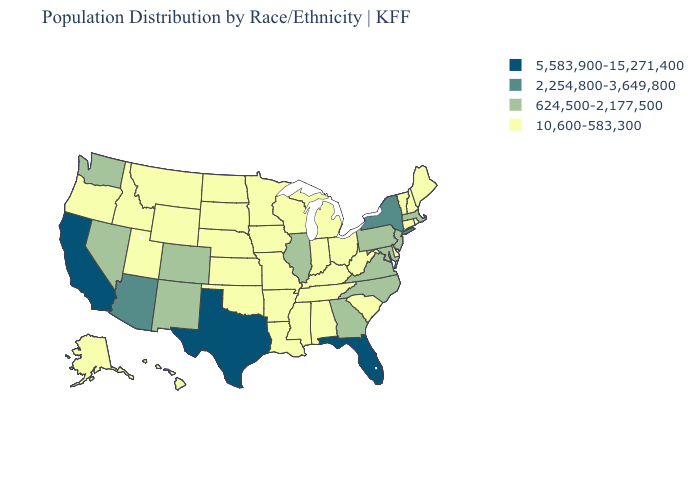Name the states that have a value in the range 2,254,800-3,649,800?
Quick response, please. Arizona, New York. Name the states that have a value in the range 2,254,800-3,649,800?
Quick response, please. Arizona, New York. Among the states that border Illinois , which have the lowest value?
Short answer required. Indiana, Iowa, Kentucky, Missouri, Wisconsin. What is the highest value in the USA?
Be succinct. 5,583,900-15,271,400. Which states have the highest value in the USA?
Short answer required. California, Florida, Texas. What is the value of Tennessee?
Concise answer only. 10,600-583,300. How many symbols are there in the legend?
Give a very brief answer. 4. Among the states that border Nevada , which have the highest value?
Short answer required. California. Among the states that border Rhode Island , does Connecticut have the highest value?
Quick response, please. No. Does Kentucky have a lower value than North Carolina?
Concise answer only. Yes. Among the states that border Indiana , does Illinois have the highest value?
Short answer required. Yes. Does California have the lowest value in the USA?
Write a very short answer. No. Which states have the lowest value in the USA?
Quick response, please. Alabama, Alaska, Arkansas, Connecticut, Delaware, Hawaii, Idaho, Indiana, Iowa, Kansas, Kentucky, Louisiana, Maine, Michigan, Minnesota, Mississippi, Missouri, Montana, Nebraska, New Hampshire, North Dakota, Ohio, Oklahoma, Oregon, Rhode Island, South Carolina, South Dakota, Tennessee, Utah, Vermont, West Virginia, Wisconsin, Wyoming. Does Georgia have the lowest value in the South?
Keep it brief. No. What is the highest value in states that border South Dakota?
Quick response, please. 10,600-583,300. 